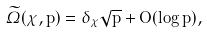<formula> <loc_0><loc_0><loc_500><loc_500>\widetilde { \varOmega } ( \chi , p ) = \delta _ { \chi } \sqrt { p } + O ( \log p ) ,</formula> 